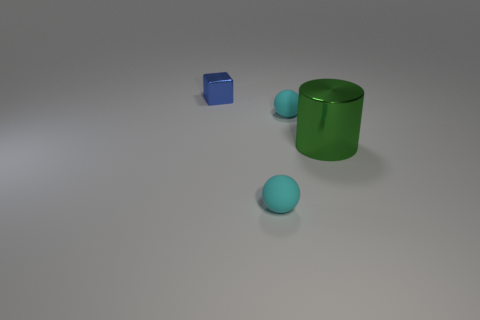Add 2 tiny red matte cylinders. How many objects exist? 6 Subtract all blocks. How many objects are left? 3 Add 4 large purple metal objects. How many large purple metal objects exist? 4 Subtract 0 brown cylinders. How many objects are left? 4 Subtract all green things. Subtract all tiny rubber balls. How many objects are left? 1 Add 1 rubber objects. How many rubber objects are left? 3 